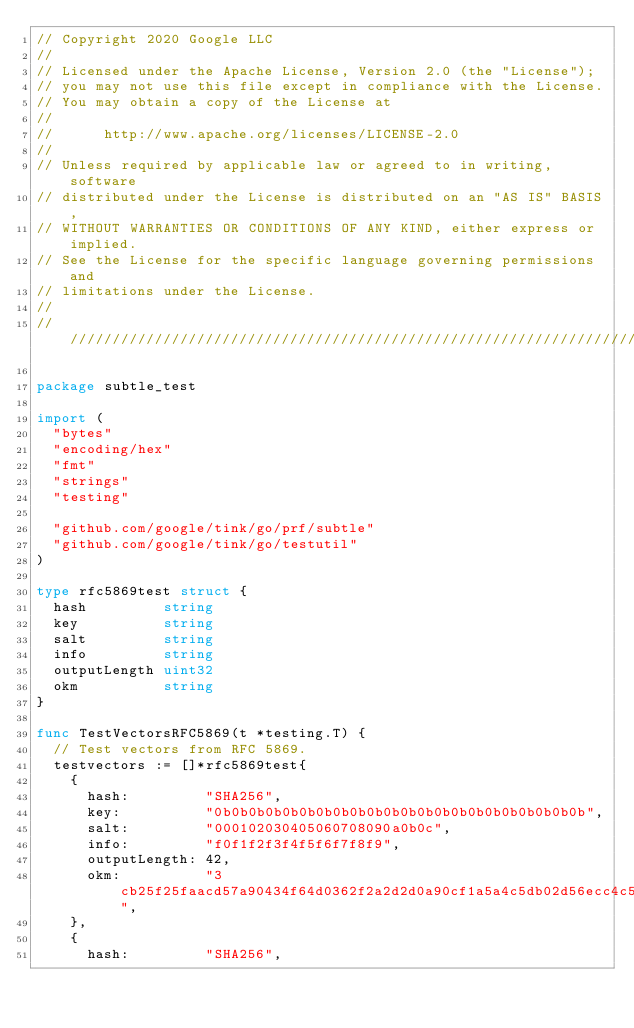<code> <loc_0><loc_0><loc_500><loc_500><_Go_>// Copyright 2020 Google LLC
//
// Licensed under the Apache License, Version 2.0 (the "License");
// you may not use this file except in compliance with the License.
// You may obtain a copy of the License at
//
//      http://www.apache.org/licenses/LICENSE-2.0
//
// Unless required by applicable law or agreed to in writing, software
// distributed under the License is distributed on an "AS IS" BASIS,
// WITHOUT WARRANTIES OR CONDITIONS OF ANY KIND, either express or implied.
// See the License for the specific language governing permissions and
// limitations under the License.
//
////////////////////////////////////////////////////////////////////////////////

package subtle_test

import (
	"bytes"
	"encoding/hex"
	"fmt"
	"strings"
	"testing"

	"github.com/google/tink/go/prf/subtle"
	"github.com/google/tink/go/testutil"
)

type rfc5869test struct {
	hash         string
	key          string
	salt         string
	info         string
	outputLength uint32
	okm          string
}

func TestVectorsRFC5869(t *testing.T) {
	// Test vectors from RFC 5869.
	testvectors := []*rfc5869test{
		{
			hash:         "SHA256",
			key:          "0b0b0b0b0b0b0b0b0b0b0b0b0b0b0b0b0b0b0b0b0b0b",
			salt:         "000102030405060708090a0b0c",
			info:         "f0f1f2f3f4f5f6f7f8f9",
			outputLength: 42,
			okm:          "3cb25f25faacd57a90434f64d0362f2a2d2d0a90cf1a5a4c5db02d56ecc4c5bf34007208d5b887185865",
		},
		{
			hash:         "SHA256",</code> 